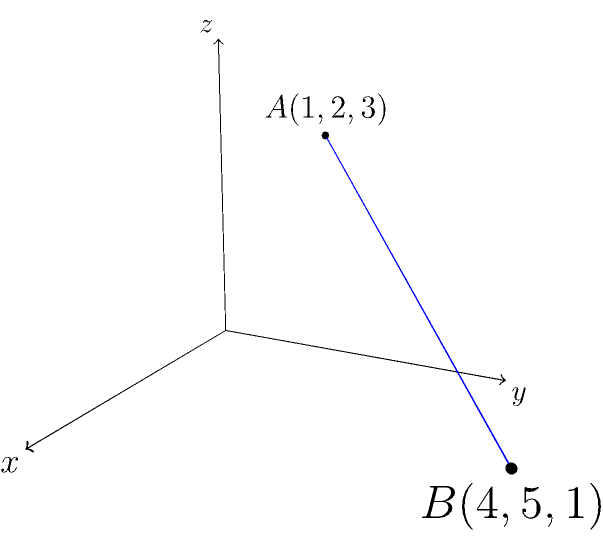In a museum exhibition on spatial perception, two interactive points are placed in a 3D space to demonstrate depth perception. Point A has coordinates (1,2,3) and point B has coordinates (4,5,1). Calculate the distance between these two points to determine the optimal viewing angle for museum visitors. How might this calculation inform the design of visual storytelling elements in the exhibition? To find the distance between two points in 3D space, we use the distance formula derived from the Pythagorean theorem in three dimensions:

$$d = \sqrt{(x_2-x_1)^2 + (y_2-y_1)^2 + (z_2-z_1)^2}$$

Where $(x_1,y_1,z_1)$ are the coordinates of point A and $(x_2,y_2,z_2)$ are the coordinates of point B.

Step 1: Identify the coordinates
A(1,2,3) and B(4,5,1)

Step 2: Substitute the values into the formula
$$d = \sqrt{(4-1)^2 + (5-2)^2 + (1-3)^2}$$

Step 3: Calculate the differences inside the parentheses
$$d = \sqrt{3^2 + 3^2 + (-2)^2}$$

Step 4: Calculate the squares
$$d = \sqrt{9 + 9 + 4}$$

Step 5: Sum the values under the square root
$$d = \sqrt{22}$$

Step 6: Simplify if possible (in this case, it cannot be simplified further)

The distance between points A and B is $\sqrt{22}$ units.

This calculation can inform the design of visual storytelling elements by:
1. Helping determine the optimal viewing distance for 3D exhibits
2. Guiding the placement of interactive elements in the space
3. Assisting in creating a sense of depth and perspective in 2D representations of 3D spaces
4. Informing the design of virtual reality experiences that accurately represent spatial relationships
Answer: $\sqrt{22}$ units 